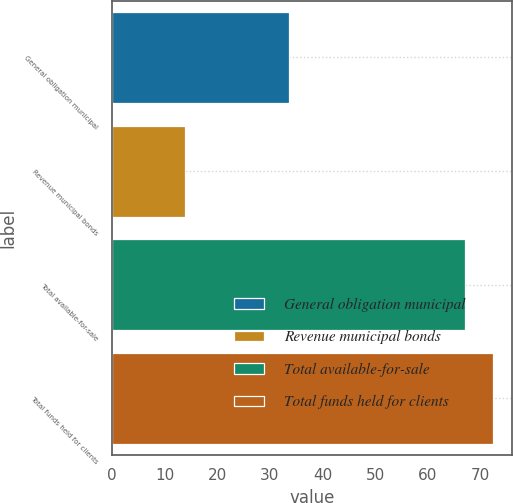<chart> <loc_0><loc_0><loc_500><loc_500><bar_chart><fcel>General obligation municipal<fcel>Revenue municipal bonds<fcel>Total available-for-sale<fcel>Total funds held for clients<nl><fcel>33.7<fcel>13.8<fcel>67<fcel>72.32<nl></chart> 